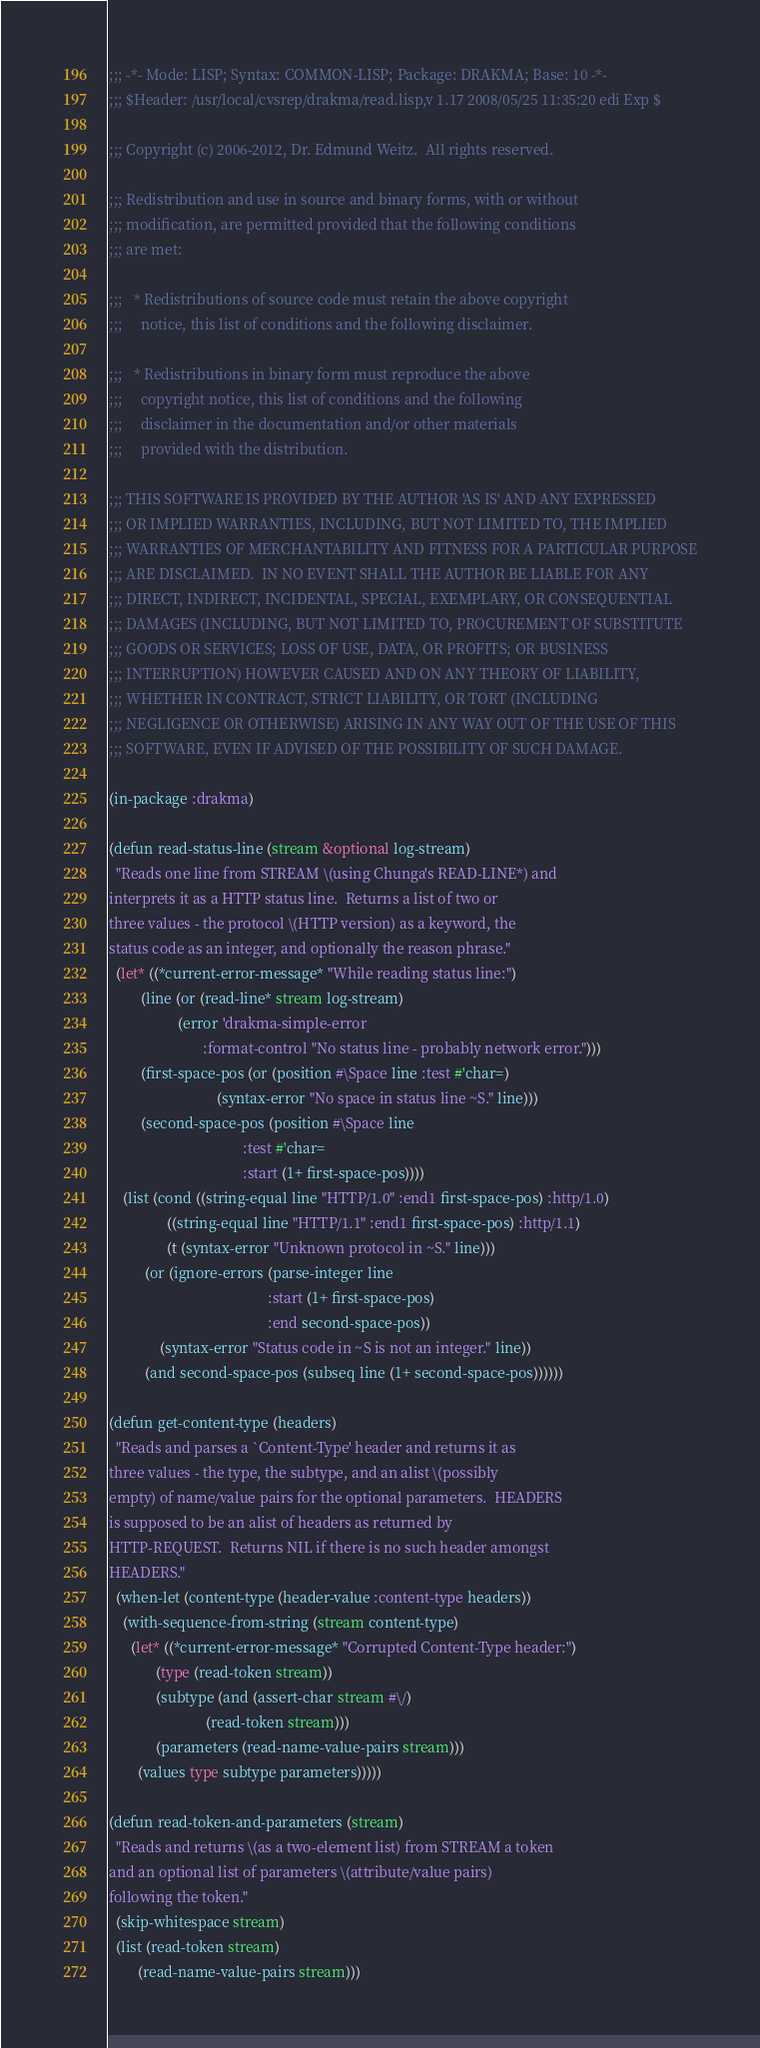Convert code to text. <code><loc_0><loc_0><loc_500><loc_500><_Lisp_>;;; -*- Mode: LISP; Syntax: COMMON-LISP; Package: DRAKMA; Base: 10 -*-
;;; $Header: /usr/local/cvsrep/drakma/read.lisp,v 1.17 2008/05/25 11:35:20 edi Exp $

;;; Copyright (c) 2006-2012, Dr. Edmund Weitz.  All rights reserved.

;;; Redistribution and use in source and binary forms, with or without
;;; modification, are permitted provided that the following conditions
;;; are met:

;;;   * Redistributions of source code must retain the above copyright
;;;     notice, this list of conditions and the following disclaimer.

;;;   * Redistributions in binary form must reproduce the above
;;;     copyright notice, this list of conditions and the following
;;;     disclaimer in the documentation and/or other materials
;;;     provided with the distribution.

;;; THIS SOFTWARE IS PROVIDED BY THE AUTHOR 'AS IS' AND ANY EXPRESSED
;;; OR IMPLIED WARRANTIES, INCLUDING, BUT NOT LIMITED TO, THE IMPLIED
;;; WARRANTIES OF MERCHANTABILITY AND FITNESS FOR A PARTICULAR PURPOSE
;;; ARE DISCLAIMED.  IN NO EVENT SHALL THE AUTHOR BE LIABLE FOR ANY
;;; DIRECT, INDIRECT, INCIDENTAL, SPECIAL, EXEMPLARY, OR CONSEQUENTIAL
;;; DAMAGES (INCLUDING, BUT NOT LIMITED TO, PROCUREMENT OF SUBSTITUTE
;;; GOODS OR SERVICES; LOSS OF USE, DATA, OR PROFITS; OR BUSINESS
;;; INTERRUPTION) HOWEVER CAUSED AND ON ANY THEORY OF LIABILITY,
;;; WHETHER IN CONTRACT, STRICT LIABILITY, OR TORT (INCLUDING
;;; NEGLIGENCE OR OTHERWISE) ARISING IN ANY WAY OUT OF THE USE OF THIS
;;; SOFTWARE, EVEN IF ADVISED OF THE POSSIBILITY OF SUCH DAMAGE.

(in-package :drakma)

(defun read-status-line (stream &optional log-stream)
  "Reads one line from STREAM \(using Chunga's READ-LINE*) and
interprets it as a HTTP status line.  Returns a list of two or
three values - the protocol \(HTTP version) as a keyword, the
status code as an integer, and optionally the reason phrase."
  (let* ((*current-error-message* "While reading status line:")
         (line (or (read-line* stream log-stream)
                   (error 'drakma-simple-error
                          :format-control "No status line - probably network error.")))
         (first-space-pos (or (position #\Space line :test #'char=)
                              (syntax-error "No space in status line ~S." line)))
         (second-space-pos (position #\Space line
                                     :test #'char=
                                     :start (1+ first-space-pos))))
    (list (cond ((string-equal line "HTTP/1.0" :end1 first-space-pos) :http/1.0)
                ((string-equal line "HTTP/1.1" :end1 first-space-pos) :http/1.1)
                (t (syntax-error "Unknown protocol in ~S." line)))
          (or (ignore-errors (parse-integer line
                                            :start (1+ first-space-pos)
                                            :end second-space-pos))
              (syntax-error "Status code in ~S is not an integer." line))
          (and second-space-pos (subseq line (1+ second-space-pos))))))

(defun get-content-type (headers)
  "Reads and parses a `Content-Type' header and returns it as
three values - the type, the subtype, and an alist \(possibly
empty) of name/value pairs for the optional parameters.  HEADERS
is supposed to be an alist of headers as returned by
HTTP-REQUEST.  Returns NIL if there is no such header amongst
HEADERS."
  (when-let (content-type (header-value :content-type headers))
    (with-sequence-from-string (stream content-type)
      (let* ((*current-error-message* "Corrupted Content-Type header:")
             (type (read-token stream))
             (subtype (and (assert-char stream #\/)
                           (read-token stream)))
             (parameters (read-name-value-pairs stream)))
        (values type subtype parameters)))))

(defun read-token-and-parameters (stream)
  "Reads and returns \(as a two-element list) from STREAM a token
and an optional list of parameters \(attribute/value pairs)
following the token."
  (skip-whitespace stream)
  (list (read-token stream)
        (read-name-value-pairs stream)))
</code> 